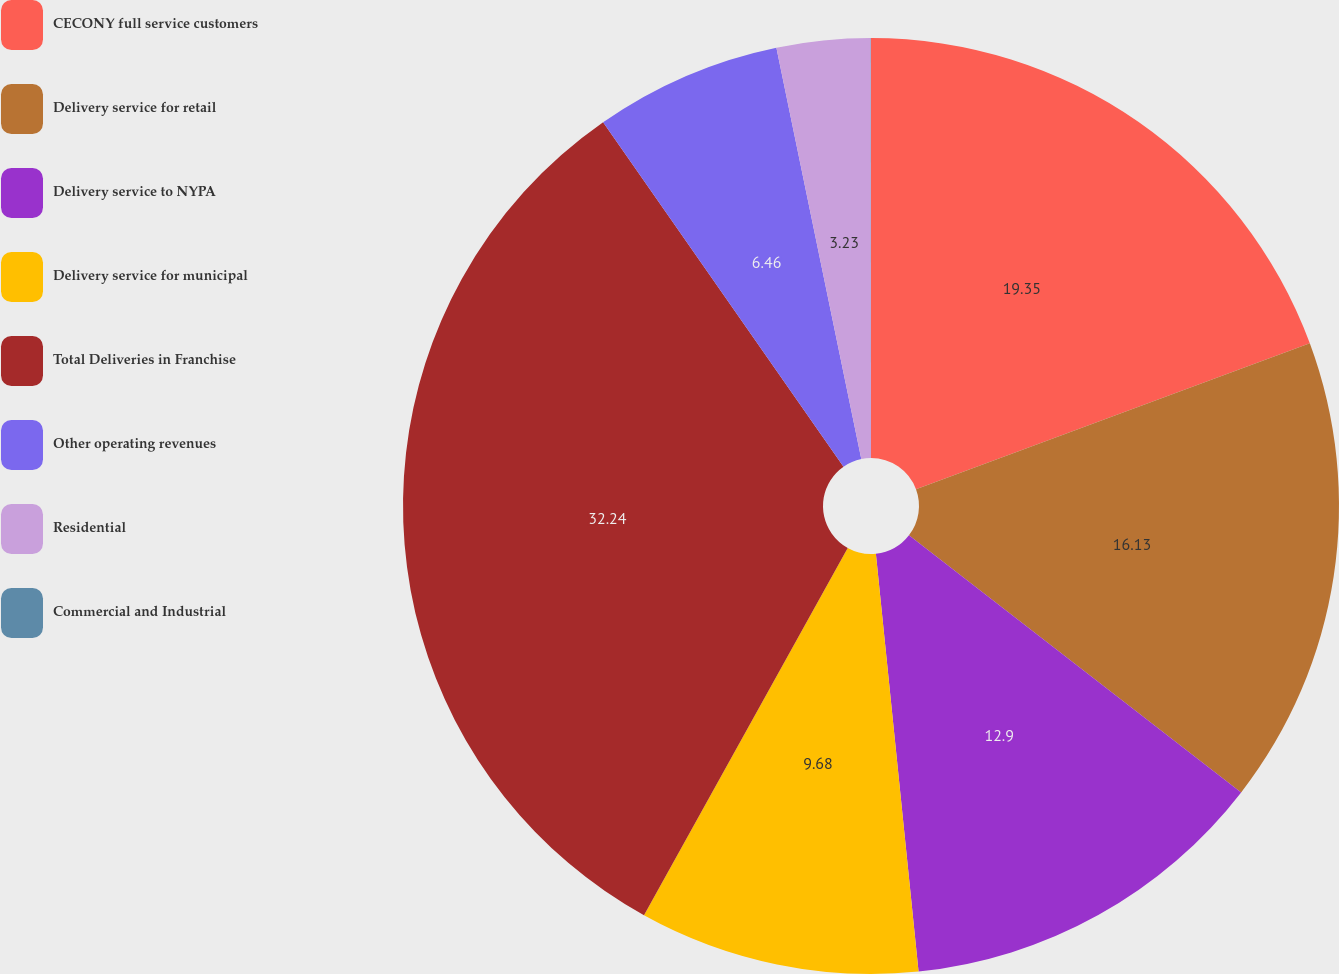Convert chart to OTSL. <chart><loc_0><loc_0><loc_500><loc_500><pie_chart><fcel>CECONY full service customers<fcel>Delivery service for retail<fcel>Delivery service to NYPA<fcel>Delivery service for municipal<fcel>Total Deliveries in Franchise<fcel>Other operating revenues<fcel>Residential<fcel>Commercial and Industrial<nl><fcel>19.35%<fcel>16.13%<fcel>12.9%<fcel>9.68%<fcel>32.24%<fcel>6.46%<fcel>3.23%<fcel>0.01%<nl></chart> 